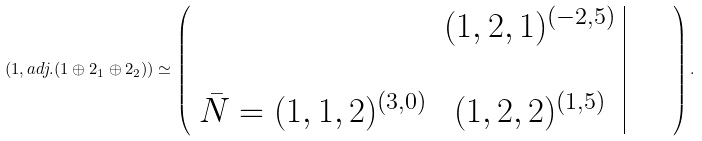<formula> <loc_0><loc_0><loc_500><loc_500>( { 1 } , { a d j . } ( { 1 } \oplus { 2 } _ { 1 } \oplus { 2 } _ { 2 } ) ) \simeq \left ( \begin{array} { c c | c } \quad & ( { 1 } , { 2 } , { 1 } ) ^ { ( - 2 , 5 ) } & \\ & & \quad \\ \bar { N } = ( { 1 } , { 1 } , { 2 } ) ^ { ( 3 , 0 ) } & ( { 1 } , { 2 } , { 2 } ) ^ { ( 1 , 5 ) } & \end{array} \right ) .</formula> 